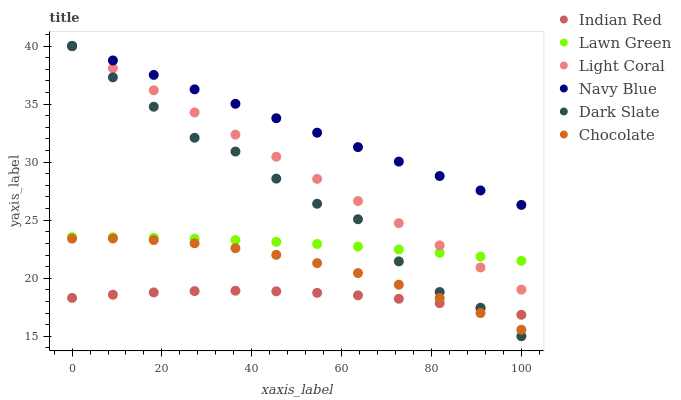Does Indian Red have the minimum area under the curve?
Answer yes or no. Yes. Does Navy Blue have the maximum area under the curve?
Answer yes or no. Yes. Does Chocolate have the minimum area under the curve?
Answer yes or no. No. Does Chocolate have the maximum area under the curve?
Answer yes or no. No. Is Light Coral the smoothest?
Answer yes or no. Yes. Is Dark Slate the roughest?
Answer yes or no. Yes. Is Navy Blue the smoothest?
Answer yes or no. No. Is Navy Blue the roughest?
Answer yes or no. No. Does Dark Slate have the lowest value?
Answer yes or no. Yes. Does Chocolate have the lowest value?
Answer yes or no. No. Does Dark Slate have the highest value?
Answer yes or no. Yes. Does Chocolate have the highest value?
Answer yes or no. No. Is Chocolate less than Navy Blue?
Answer yes or no. Yes. Is Lawn Green greater than Indian Red?
Answer yes or no. Yes. Does Lawn Green intersect Light Coral?
Answer yes or no. Yes. Is Lawn Green less than Light Coral?
Answer yes or no. No. Is Lawn Green greater than Light Coral?
Answer yes or no. No. Does Chocolate intersect Navy Blue?
Answer yes or no. No. 